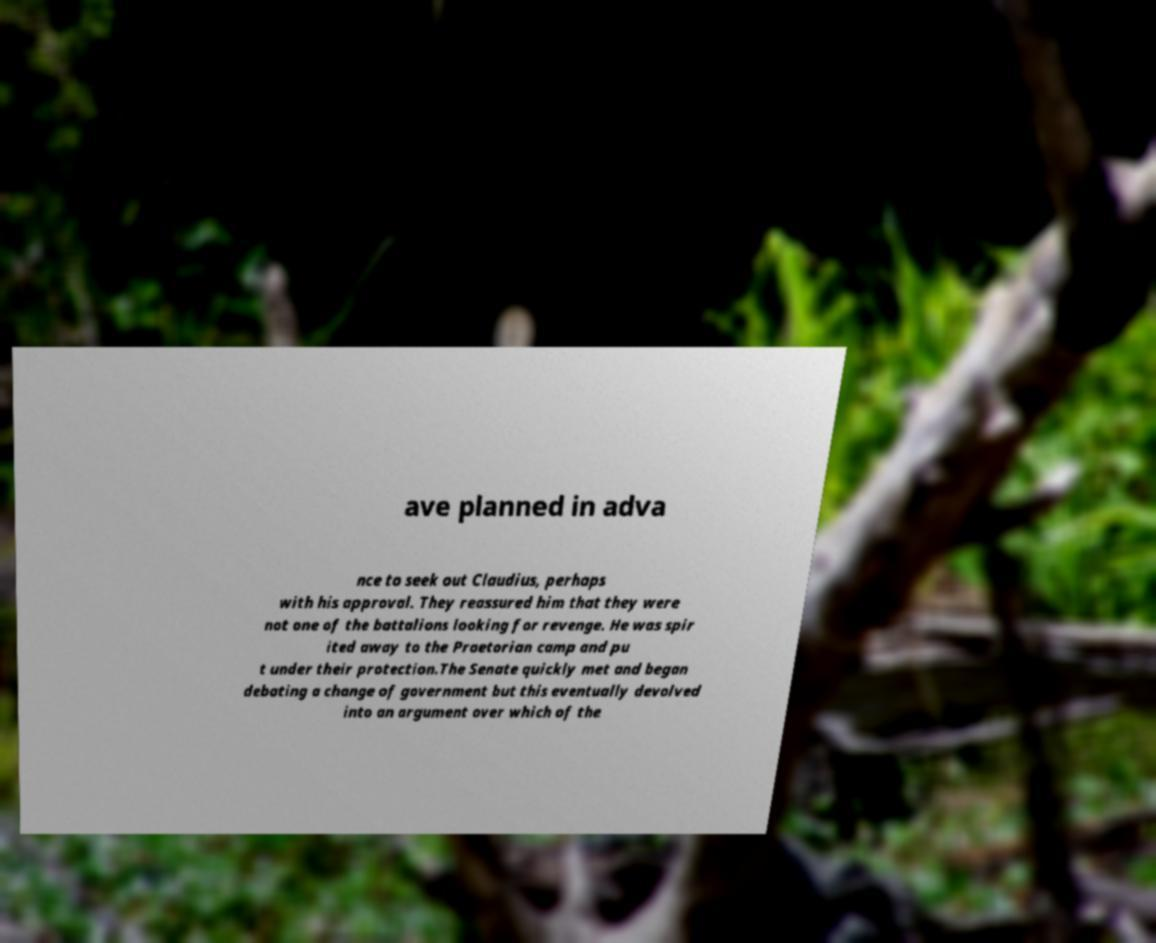Could you assist in decoding the text presented in this image and type it out clearly? ave planned in adva nce to seek out Claudius, perhaps with his approval. They reassured him that they were not one of the battalions looking for revenge. He was spir ited away to the Praetorian camp and pu t under their protection.The Senate quickly met and began debating a change of government but this eventually devolved into an argument over which of the 